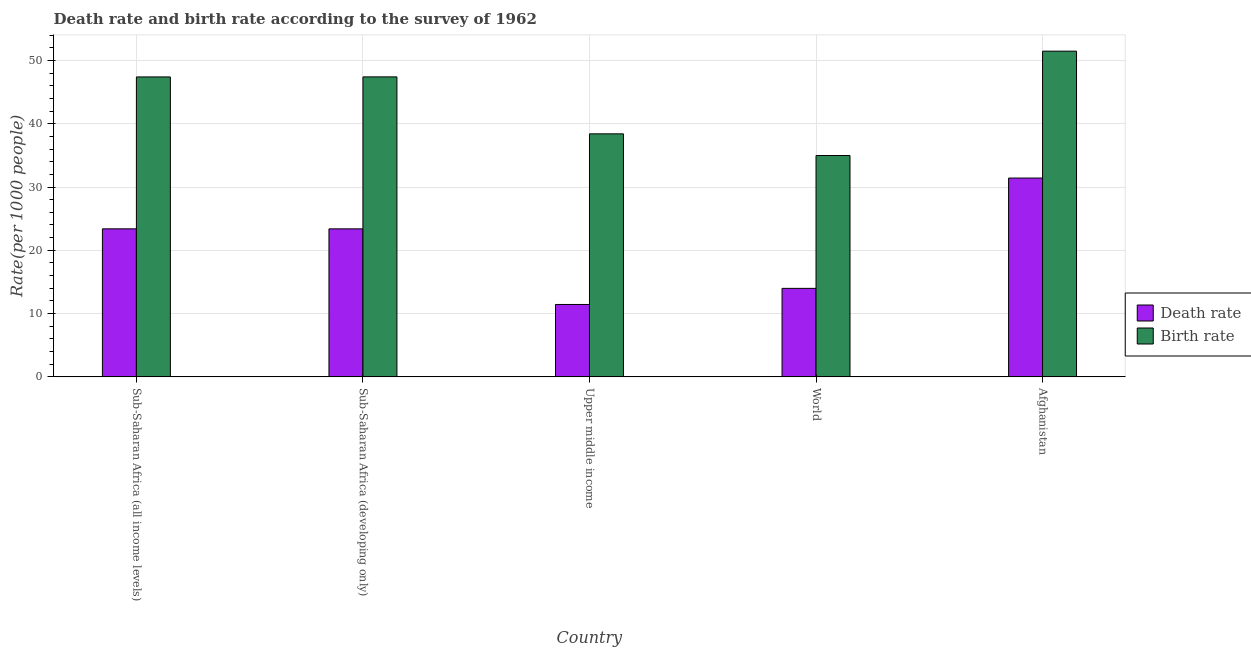How many groups of bars are there?
Provide a short and direct response. 5. Are the number of bars per tick equal to the number of legend labels?
Your answer should be very brief. Yes. Are the number of bars on each tick of the X-axis equal?
Provide a succinct answer. Yes. What is the birth rate in Sub-Saharan Africa (all income levels)?
Your response must be concise. 47.39. Across all countries, what is the maximum death rate?
Offer a very short reply. 31.41. Across all countries, what is the minimum birth rate?
Your answer should be compact. 34.97. In which country was the birth rate maximum?
Keep it short and to the point. Afghanistan. In which country was the death rate minimum?
Offer a very short reply. Upper middle income. What is the total death rate in the graph?
Make the answer very short. 103.62. What is the difference between the death rate in Afghanistan and that in World?
Give a very brief answer. 17.43. What is the difference between the death rate in Sub-Saharan Africa (all income levels) and the birth rate in Upper middle income?
Make the answer very short. -15.01. What is the average death rate per country?
Your response must be concise. 20.72. What is the difference between the birth rate and death rate in Upper middle income?
Give a very brief answer. 26.96. What is the ratio of the death rate in Afghanistan to that in Sub-Saharan Africa (developing only)?
Your answer should be very brief. 1.34. Is the death rate in Afghanistan less than that in Upper middle income?
Ensure brevity in your answer.  No. What is the difference between the highest and the second highest death rate?
Provide a short and direct response. 8.02. What is the difference between the highest and the lowest death rate?
Offer a very short reply. 19.98. Is the sum of the death rate in Sub-Saharan Africa (all income levels) and World greater than the maximum birth rate across all countries?
Provide a succinct answer. No. What does the 1st bar from the left in World represents?
Give a very brief answer. Death rate. What does the 1st bar from the right in Sub-Saharan Africa (developing only) represents?
Offer a very short reply. Birth rate. How many bars are there?
Make the answer very short. 10. How many countries are there in the graph?
Offer a very short reply. 5. What is the difference between two consecutive major ticks on the Y-axis?
Your answer should be compact. 10. How many legend labels are there?
Offer a terse response. 2. What is the title of the graph?
Ensure brevity in your answer.  Death rate and birth rate according to the survey of 1962. Does "Boys" appear as one of the legend labels in the graph?
Provide a succinct answer. No. What is the label or title of the Y-axis?
Provide a short and direct response. Rate(per 1000 people). What is the Rate(per 1000 people) in Death rate in Sub-Saharan Africa (all income levels)?
Your response must be concise. 23.39. What is the Rate(per 1000 people) in Birth rate in Sub-Saharan Africa (all income levels)?
Give a very brief answer. 47.39. What is the Rate(per 1000 people) of Death rate in Sub-Saharan Africa (developing only)?
Offer a very short reply. 23.39. What is the Rate(per 1000 people) of Birth rate in Sub-Saharan Africa (developing only)?
Your response must be concise. 47.4. What is the Rate(per 1000 people) of Death rate in Upper middle income?
Your response must be concise. 11.44. What is the Rate(per 1000 people) in Birth rate in Upper middle income?
Provide a succinct answer. 38.4. What is the Rate(per 1000 people) in Death rate in World?
Keep it short and to the point. 13.98. What is the Rate(per 1000 people) of Birth rate in World?
Make the answer very short. 34.97. What is the Rate(per 1000 people) of Death rate in Afghanistan?
Provide a succinct answer. 31.41. What is the Rate(per 1000 people) of Birth rate in Afghanistan?
Provide a succinct answer. 51.46. Across all countries, what is the maximum Rate(per 1000 people) in Death rate?
Provide a succinct answer. 31.41. Across all countries, what is the maximum Rate(per 1000 people) of Birth rate?
Keep it short and to the point. 51.46. Across all countries, what is the minimum Rate(per 1000 people) in Death rate?
Make the answer very short. 11.44. Across all countries, what is the minimum Rate(per 1000 people) of Birth rate?
Your response must be concise. 34.97. What is the total Rate(per 1000 people) of Death rate in the graph?
Provide a succinct answer. 103.62. What is the total Rate(per 1000 people) in Birth rate in the graph?
Your answer should be very brief. 219.63. What is the difference between the Rate(per 1000 people) of Death rate in Sub-Saharan Africa (all income levels) and that in Sub-Saharan Africa (developing only)?
Provide a short and direct response. 0. What is the difference between the Rate(per 1000 people) in Birth rate in Sub-Saharan Africa (all income levels) and that in Sub-Saharan Africa (developing only)?
Provide a short and direct response. -0.01. What is the difference between the Rate(per 1000 people) in Death rate in Sub-Saharan Africa (all income levels) and that in Upper middle income?
Give a very brief answer. 11.95. What is the difference between the Rate(per 1000 people) of Birth rate in Sub-Saharan Africa (all income levels) and that in Upper middle income?
Ensure brevity in your answer.  8.99. What is the difference between the Rate(per 1000 people) of Death rate in Sub-Saharan Africa (all income levels) and that in World?
Give a very brief answer. 9.41. What is the difference between the Rate(per 1000 people) in Birth rate in Sub-Saharan Africa (all income levels) and that in World?
Provide a short and direct response. 12.42. What is the difference between the Rate(per 1000 people) in Death rate in Sub-Saharan Africa (all income levels) and that in Afghanistan?
Make the answer very short. -8.02. What is the difference between the Rate(per 1000 people) of Birth rate in Sub-Saharan Africa (all income levels) and that in Afghanistan?
Your answer should be compact. -4.07. What is the difference between the Rate(per 1000 people) in Death rate in Sub-Saharan Africa (developing only) and that in Upper middle income?
Offer a terse response. 11.95. What is the difference between the Rate(per 1000 people) of Birth rate in Sub-Saharan Africa (developing only) and that in Upper middle income?
Your answer should be compact. 9. What is the difference between the Rate(per 1000 people) of Death rate in Sub-Saharan Africa (developing only) and that in World?
Offer a very short reply. 9.4. What is the difference between the Rate(per 1000 people) of Birth rate in Sub-Saharan Africa (developing only) and that in World?
Make the answer very short. 12.43. What is the difference between the Rate(per 1000 people) of Death rate in Sub-Saharan Africa (developing only) and that in Afghanistan?
Offer a very short reply. -8.03. What is the difference between the Rate(per 1000 people) in Birth rate in Sub-Saharan Africa (developing only) and that in Afghanistan?
Provide a succinct answer. -4.06. What is the difference between the Rate(per 1000 people) in Death rate in Upper middle income and that in World?
Offer a very short reply. -2.54. What is the difference between the Rate(per 1000 people) in Birth rate in Upper middle income and that in World?
Offer a very short reply. 3.43. What is the difference between the Rate(per 1000 people) of Death rate in Upper middle income and that in Afghanistan?
Ensure brevity in your answer.  -19.98. What is the difference between the Rate(per 1000 people) in Birth rate in Upper middle income and that in Afghanistan?
Provide a succinct answer. -13.06. What is the difference between the Rate(per 1000 people) of Death rate in World and that in Afghanistan?
Ensure brevity in your answer.  -17.43. What is the difference between the Rate(per 1000 people) of Birth rate in World and that in Afghanistan?
Provide a succinct answer. -16.49. What is the difference between the Rate(per 1000 people) of Death rate in Sub-Saharan Africa (all income levels) and the Rate(per 1000 people) of Birth rate in Sub-Saharan Africa (developing only)?
Provide a short and direct response. -24.01. What is the difference between the Rate(per 1000 people) in Death rate in Sub-Saharan Africa (all income levels) and the Rate(per 1000 people) in Birth rate in Upper middle income?
Your answer should be compact. -15.01. What is the difference between the Rate(per 1000 people) in Death rate in Sub-Saharan Africa (all income levels) and the Rate(per 1000 people) in Birth rate in World?
Your response must be concise. -11.58. What is the difference between the Rate(per 1000 people) of Death rate in Sub-Saharan Africa (all income levels) and the Rate(per 1000 people) of Birth rate in Afghanistan?
Provide a short and direct response. -28.07. What is the difference between the Rate(per 1000 people) of Death rate in Sub-Saharan Africa (developing only) and the Rate(per 1000 people) of Birth rate in Upper middle income?
Your answer should be compact. -15.01. What is the difference between the Rate(per 1000 people) of Death rate in Sub-Saharan Africa (developing only) and the Rate(per 1000 people) of Birth rate in World?
Your response must be concise. -11.59. What is the difference between the Rate(per 1000 people) in Death rate in Sub-Saharan Africa (developing only) and the Rate(per 1000 people) in Birth rate in Afghanistan?
Provide a short and direct response. -28.08. What is the difference between the Rate(per 1000 people) of Death rate in Upper middle income and the Rate(per 1000 people) of Birth rate in World?
Your response must be concise. -23.53. What is the difference between the Rate(per 1000 people) of Death rate in Upper middle income and the Rate(per 1000 people) of Birth rate in Afghanistan?
Offer a very short reply. -40.02. What is the difference between the Rate(per 1000 people) of Death rate in World and the Rate(per 1000 people) of Birth rate in Afghanistan?
Your answer should be very brief. -37.48. What is the average Rate(per 1000 people) in Death rate per country?
Make the answer very short. 20.72. What is the average Rate(per 1000 people) of Birth rate per country?
Your response must be concise. 43.93. What is the difference between the Rate(per 1000 people) in Death rate and Rate(per 1000 people) in Birth rate in Sub-Saharan Africa (all income levels)?
Ensure brevity in your answer.  -24. What is the difference between the Rate(per 1000 people) in Death rate and Rate(per 1000 people) in Birth rate in Sub-Saharan Africa (developing only)?
Provide a succinct answer. -24.01. What is the difference between the Rate(per 1000 people) in Death rate and Rate(per 1000 people) in Birth rate in Upper middle income?
Your answer should be very brief. -26.96. What is the difference between the Rate(per 1000 people) in Death rate and Rate(per 1000 people) in Birth rate in World?
Offer a very short reply. -20.99. What is the difference between the Rate(per 1000 people) in Death rate and Rate(per 1000 people) in Birth rate in Afghanistan?
Offer a very short reply. -20.05. What is the ratio of the Rate(per 1000 people) in Death rate in Sub-Saharan Africa (all income levels) to that in Upper middle income?
Give a very brief answer. 2.04. What is the ratio of the Rate(per 1000 people) of Birth rate in Sub-Saharan Africa (all income levels) to that in Upper middle income?
Provide a succinct answer. 1.23. What is the ratio of the Rate(per 1000 people) of Death rate in Sub-Saharan Africa (all income levels) to that in World?
Offer a very short reply. 1.67. What is the ratio of the Rate(per 1000 people) in Birth rate in Sub-Saharan Africa (all income levels) to that in World?
Give a very brief answer. 1.36. What is the ratio of the Rate(per 1000 people) of Death rate in Sub-Saharan Africa (all income levels) to that in Afghanistan?
Make the answer very short. 0.74. What is the ratio of the Rate(per 1000 people) of Birth rate in Sub-Saharan Africa (all income levels) to that in Afghanistan?
Provide a short and direct response. 0.92. What is the ratio of the Rate(per 1000 people) of Death rate in Sub-Saharan Africa (developing only) to that in Upper middle income?
Offer a very short reply. 2.04. What is the ratio of the Rate(per 1000 people) in Birth rate in Sub-Saharan Africa (developing only) to that in Upper middle income?
Provide a succinct answer. 1.23. What is the ratio of the Rate(per 1000 people) of Death rate in Sub-Saharan Africa (developing only) to that in World?
Provide a short and direct response. 1.67. What is the ratio of the Rate(per 1000 people) in Birth rate in Sub-Saharan Africa (developing only) to that in World?
Your response must be concise. 1.36. What is the ratio of the Rate(per 1000 people) in Death rate in Sub-Saharan Africa (developing only) to that in Afghanistan?
Provide a succinct answer. 0.74. What is the ratio of the Rate(per 1000 people) in Birth rate in Sub-Saharan Africa (developing only) to that in Afghanistan?
Provide a short and direct response. 0.92. What is the ratio of the Rate(per 1000 people) in Death rate in Upper middle income to that in World?
Your response must be concise. 0.82. What is the ratio of the Rate(per 1000 people) in Birth rate in Upper middle income to that in World?
Provide a short and direct response. 1.1. What is the ratio of the Rate(per 1000 people) of Death rate in Upper middle income to that in Afghanistan?
Provide a succinct answer. 0.36. What is the ratio of the Rate(per 1000 people) in Birth rate in Upper middle income to that in Afghanistan?
Make the answer very short. 0.75. What is the ratio of the Rate(per 1000 people) in Death rate in World to that in Afghanistan?
Make the answer very short. 0.45. What is the ratio of the Rate(per 1000 people) of Birth rate in World to that in Afghanistan?
Keep it short and to the point. 0.68. What is the difference between the highest and the second highest Rate(per 1000 people) in Death rate?
Offer a terse response. 8.02. What is the difference between the highest and the second highest Rate(per 1000 people) of Birth rate?
Provide a short and direct response. 4.06. What is the difference between the highest and the lowest Rate(per 1000 people) in Death rate?
Your response must be concise. 19.98. What is the difference between the highest and the lowest Rate(per 1000 people) in Birth rate?
Provide a succinct answer. 16.49. 